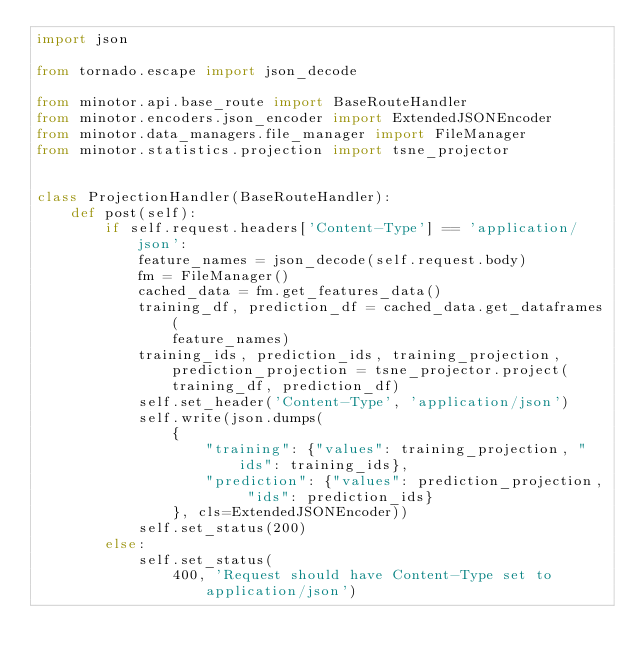<code> <loc_0><loc_0><loc_500><loc_500><_Python_>import json

from tornado.escape import json_decode

from minotor.api.base_route import BaseRouteHandler
from minotor.encoders.json_encoder import ExtendedJSONEncoder
from minotor.data_managers.file_manager import FileManager
from minotor.statistics.projection import tsne_projector


class ProjectionHandler(BaseRouteHandler):
    def post(self):
        if self.request.headers['Content-Type'] == 'application/json':
            feature_names = json_decode(self.request.body)
            fm = FileManager()
            cached_data = fm.get_features_data()
            training_df, prediction_df = cached_data.get_dataframes(
                feature_names)
            training_ids, prediction_ids, training_projection, prediction_projection = tsne_projector.project(
                training_df, prediction_df)
            self.set_header('Content-Type', 'application/json')
            self.write(json.dumps(
                {
                    "training": {"values": training_projection, "ids": training_ids},
                    "prediction": {"values": prediction_projection, "ids": prediction_ids}
                }, cls=ExtendedJSONEncoder))
            self.set_status(200)
        else:
            self.set_status(
                400, 'Request should have Content-Type set to application/json')
</code> 